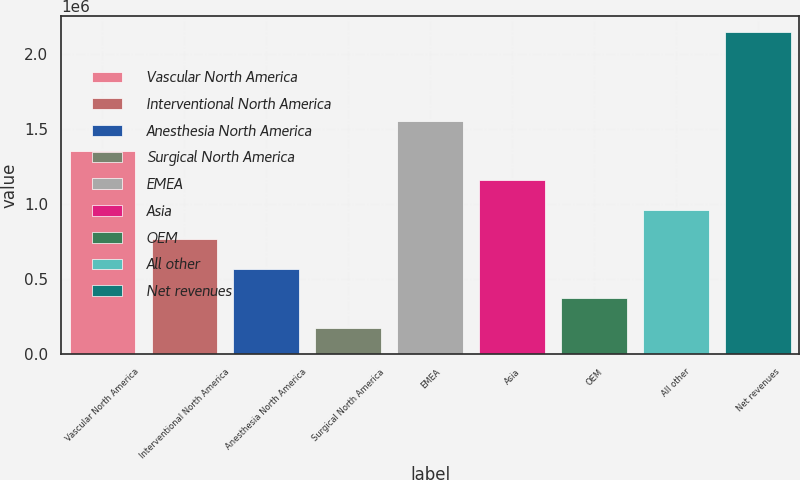<chart> <loc_0><loc_0><loc_500><loc_500><bar_chart><fcel>Vascular North America<fcel>Interventional North America<fcel>Anesthesia North America<fcel>Surgical North America<fcel>EMEA<fcel>Asia<fcel>OEM<fcel>All other<fcel>Net revenues<nl><fcel>1.35787e+06<fcel>766542<fcel>569433<fcel>175216<fcel>1.55498e+06<fcel>1.16076e+06<fcel>372325<fcel>963651<fcel>2.1463e+06<nl></chart> 